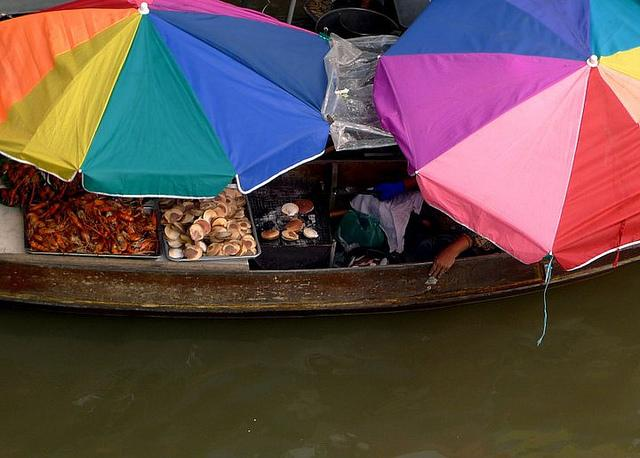What sort of food is being moved here? seafood 